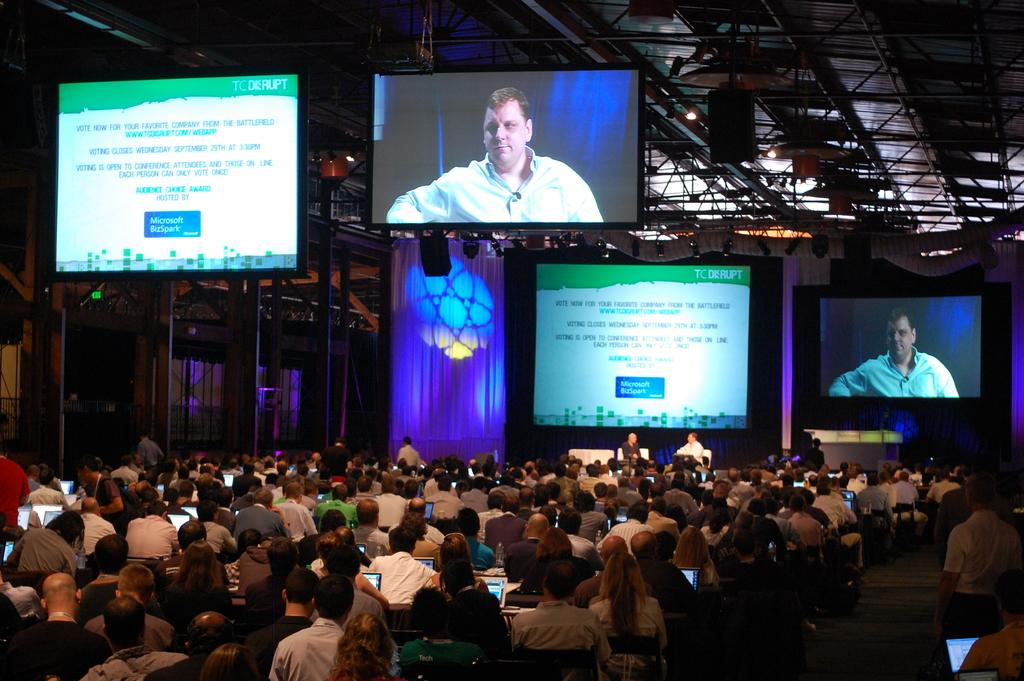<image>
Provide a brief description of the given image. A screen at a conference says "Microsoft BizSpark" in a blue box. 